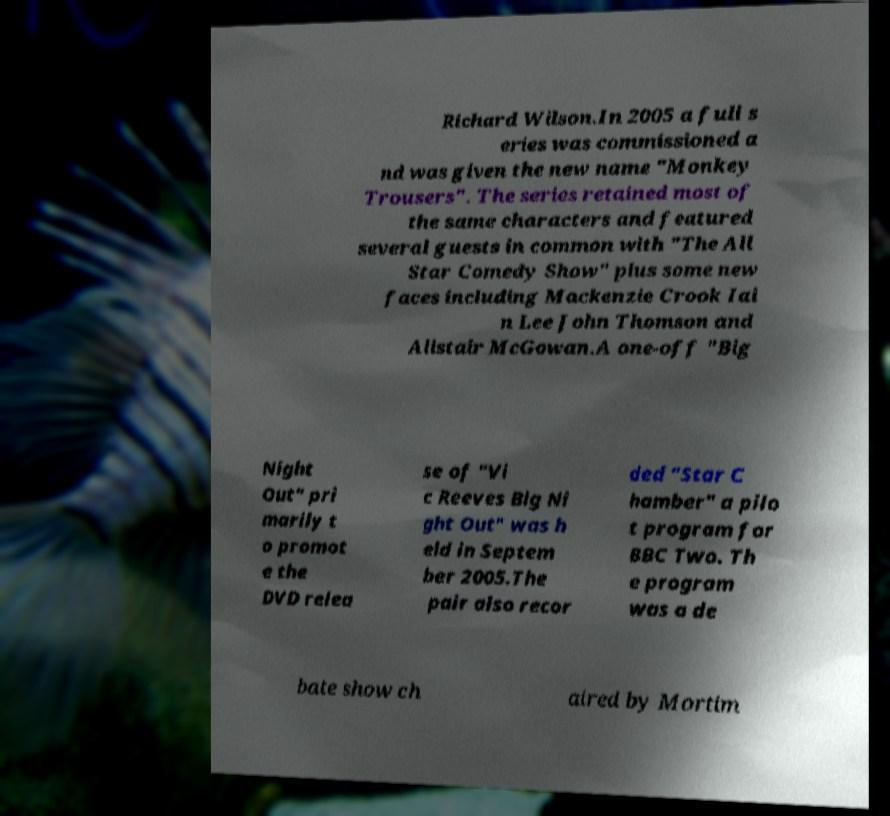Could you assist in decoding the text presented in this image and type it out clearly? Richard Wilson.In 2005 a full s eries was commissioned a nd was given the new name "Monkey Trousers". The series retained most of the same characters and featured several guests in common with "The All Star Comedy Show" plus some new faces including Mackenzie Crook Iai n Lee John Thomson and Alistair McGowan.A one-off "Big Night Out" pri marily t o promot e the DVD relea se of "Vi c Reeves Big Ni ght Out" was h eld in Septem ber 2005.The pair also recor ded "Star C hamber" a pilo t program for BBC Two. Th e program was a de bate show ch aired by Mortim 